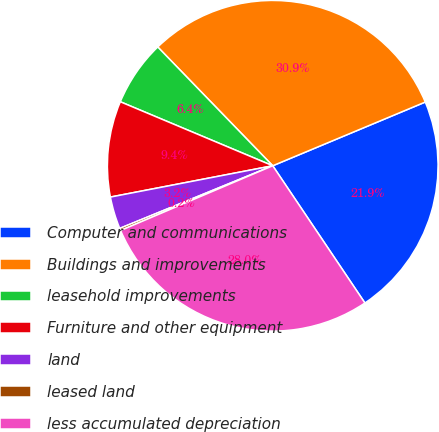Convert chart to OTSL. <chart><loc_0><loc_0><loc_500><loc_500><pie_chart><fcel>Computer and communications<fcel>Buildings and improvements<fcel>leasehold improvements<fcel>Furniture and other equipment<fcel>land<fcel>leased land<fcel>less accumulated depreciation<nl><fcel>21.88%<fcel>30.94%<fcel>6.43%<fcel>9.36%<fcel>3.15%<fcel>0.22%<fcel>28.01%<nl></chart> 